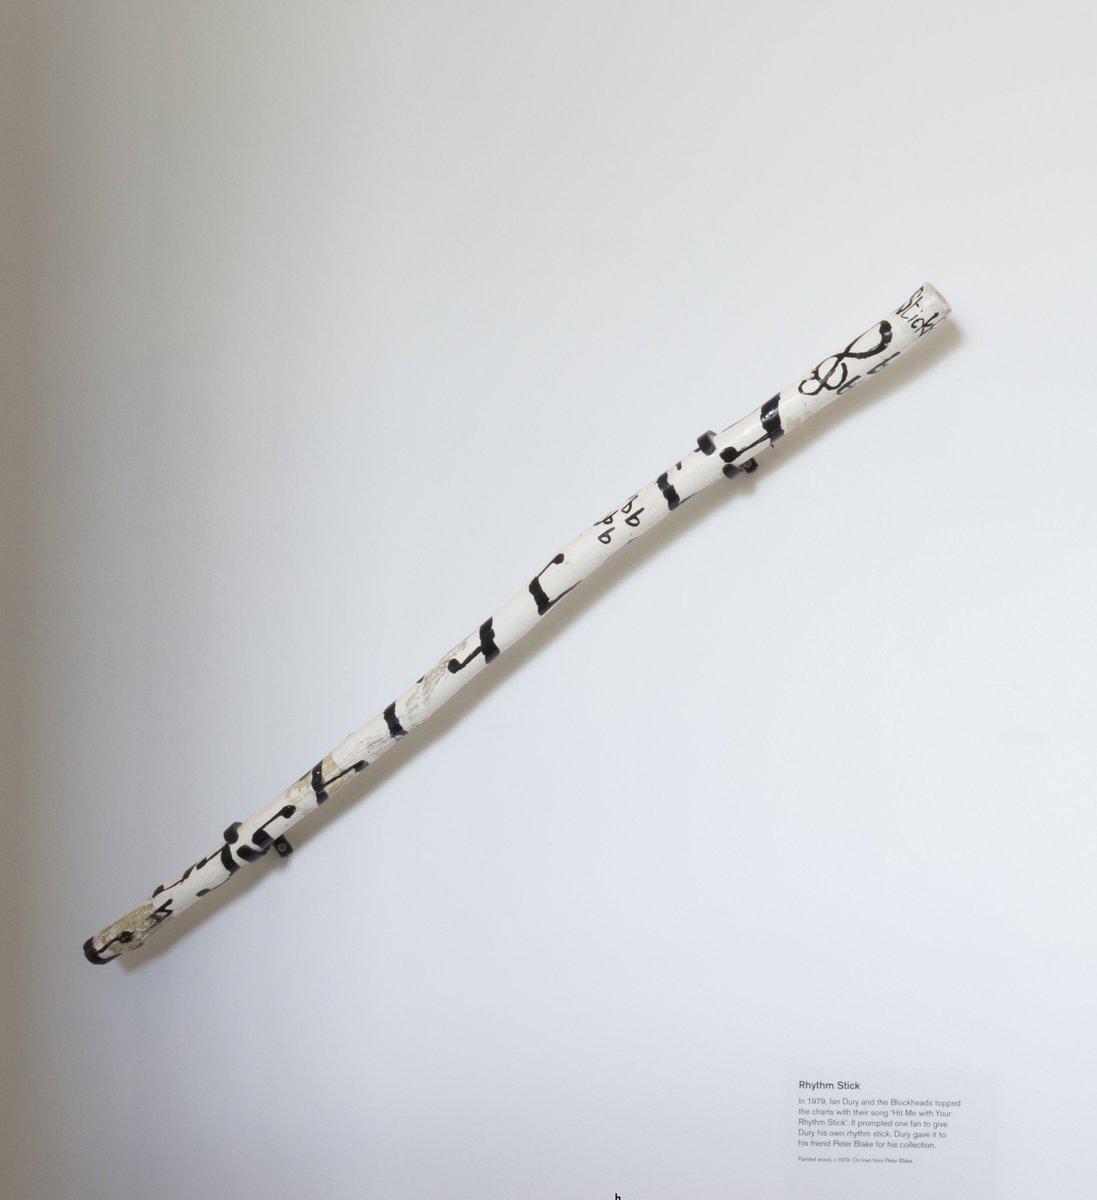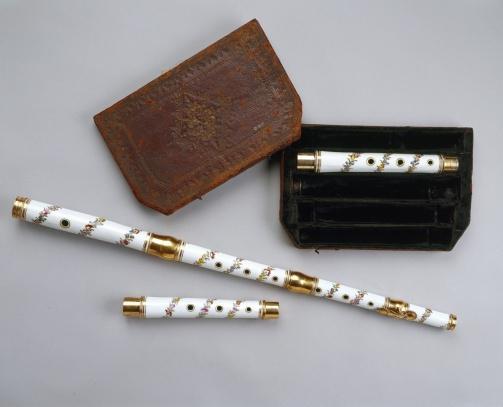The first image is the image on the left, the second image is the image on the right. Assess this claim about the two images: "The right image shows a small wind instrument decorated with a wrapped garland and posed with 2 smaller sections and a carved wood carrying case.". Correct or not? Answer yes or no. Yes. The first image is the image on the left, the second image is the image on the right. Analyze the images presented: Is the assertion "There are two instruments in the image on the left." valid? Answer yes or no. No. 